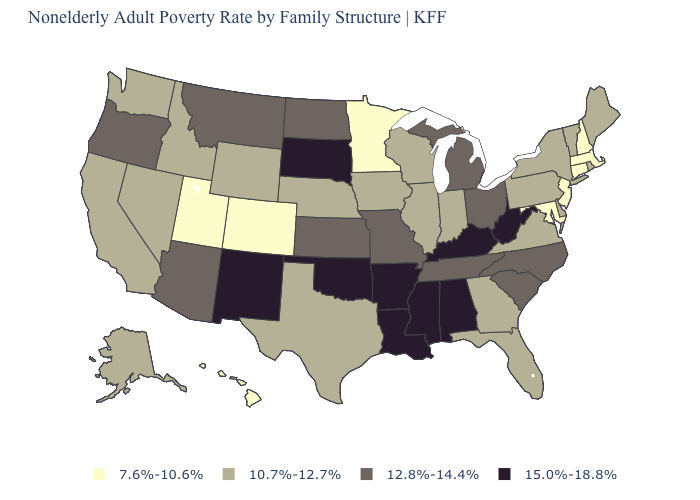Among the states that border Wisconsin , does Michigan have the lowest value?
Short answer required. No. What is the value of Arizona?
Give a very brief answer. 12.8%-14.4%. What is the value of Alabama?
Give a very brief answer. 15.0%-18.8%. Name the states that have a value in the range 12.8%-14.4%?
Write a very short answer. Arizona, Kansas, Michigan, Missouri, Montana, North Carolina, North Dakota, Ohio, Oregon, South Carolina, Tennessee. What is the value of California?
Be succinct. 10.7%-12.7%. Name the states that have a value in the range 7.6%-10.6%?
Concise answer only. Colorado, Connecticut, Hawaii, Maryland, Massachusetts, Minnesota, New Hampshire, New Jersey, Utah. Does California have a higher value than Maryland?
Quick response, please. Yes. What is the value of Illinois?
Short answer required. 10.7%-12.7%. What is the value of Kentucky?
Write a very short answer. 15.0%-18.8%. Does the map have missing data?
Answer briefly. No. Which states have the highest value in the USA?
Short answer required. Alabama, Arkansas, Kentucky, Louisiana, Mississippi, New Mexico, Oklahoma, South Dakota, West Virginia. Does Montana have the highest value in the USA?
Be succinct. No. What is the highest value in the USA?
Give a very brief answer. 15.0%-18.8%. What is the value of Oklahoma?
Concise answer only. 15.0%-18.8%. What is the highest value in the West ?
Concise answer only. 15.0%-18.8%. 